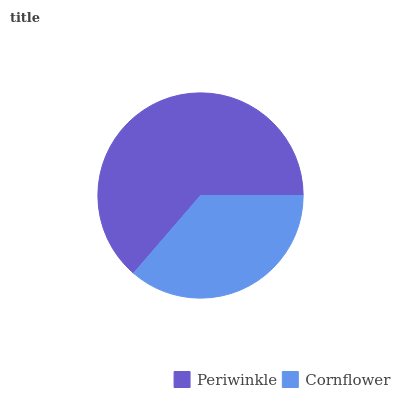Is Cornflower the minimum?
Answer yes or no. Yes. Is Periwinkle the maximum?
Answer yes or no. Yes. Is Cornflower the maximum?
Answer yes or no. No. Is Periwinkle greater than Cornflower?
Answer yes or no. Yes. Is Cornflower less than Periwinkle?
Answer yes or no. Yes. Is Cornflower greater than Periwinkle?
Answer yes or no. No. Is Periwinkle less than Cornflower?
Answer yes or no. No. Is Periwinkle the high median?
Answer yes or no. Yes. Is Cornflower the low median?
Answer yes or no. Yes. Is Cornflower the high median?
Answer yes or no. No. Is Periwinkle the low median?
Answer yes or no. No. 